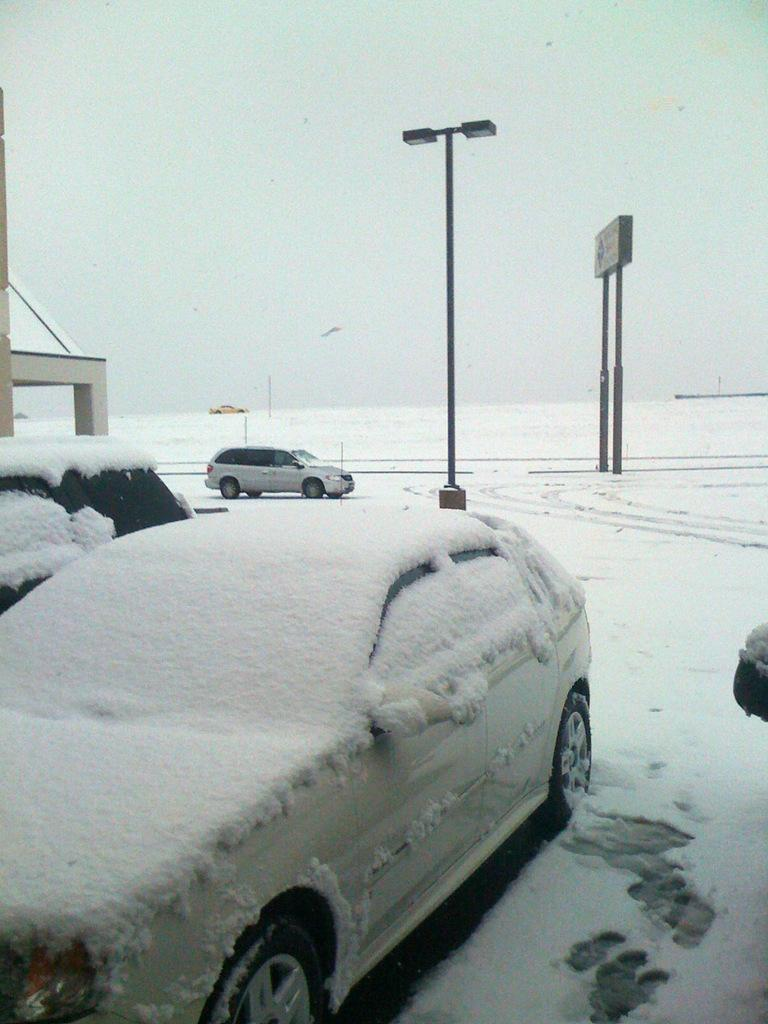What is the main feature of the landscape in the image? There is snow in the image. What artificial light source is present in the image? There is a street lamp in the image. What type of signage is visible in the image? There is a banner in the image. What type of vehicles can be seen in the image? There are cars in the image. What is visible in the sky in the image? The sky is visible in the image. How many women are visible on the floor in the image? There are no women visible on the floor in the image, as the image features snow, a street lamp, a banner, cars, and a visible sky. 